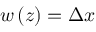Convert formula to latex. <formula><loc_0><loc_0><loc_500><loc_500>w \left ( z \right ) = \Delta x</formula> 